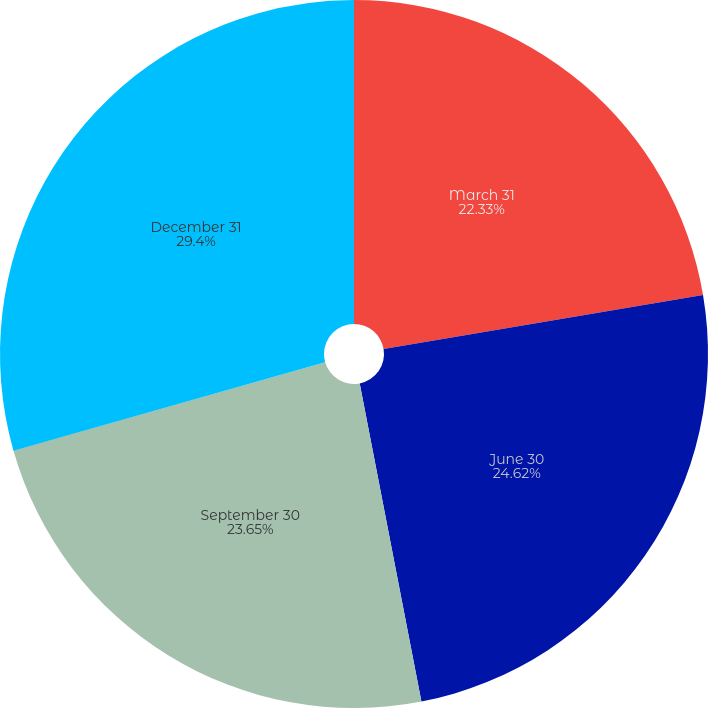<chart> <loc_0><loc_0><loc_500><loc_500><pie_chart><fcel>March 31<fcel>June 30<fcel>September 30<fcel>December 31<nl><fcel>22.33%<fcel>24.62%<fcel>23.65%<fcel>29.4%<nl></chart> 